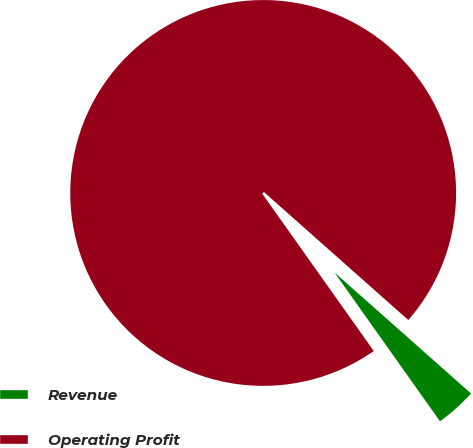Convert chart. <chart><loc_0><loc_0><loc_500><loc_500><pie_chart><fcel>Revenue<fcel>Operating Profit<nl><fcel>3.64%<fcel>96.36%<nl></chart> 